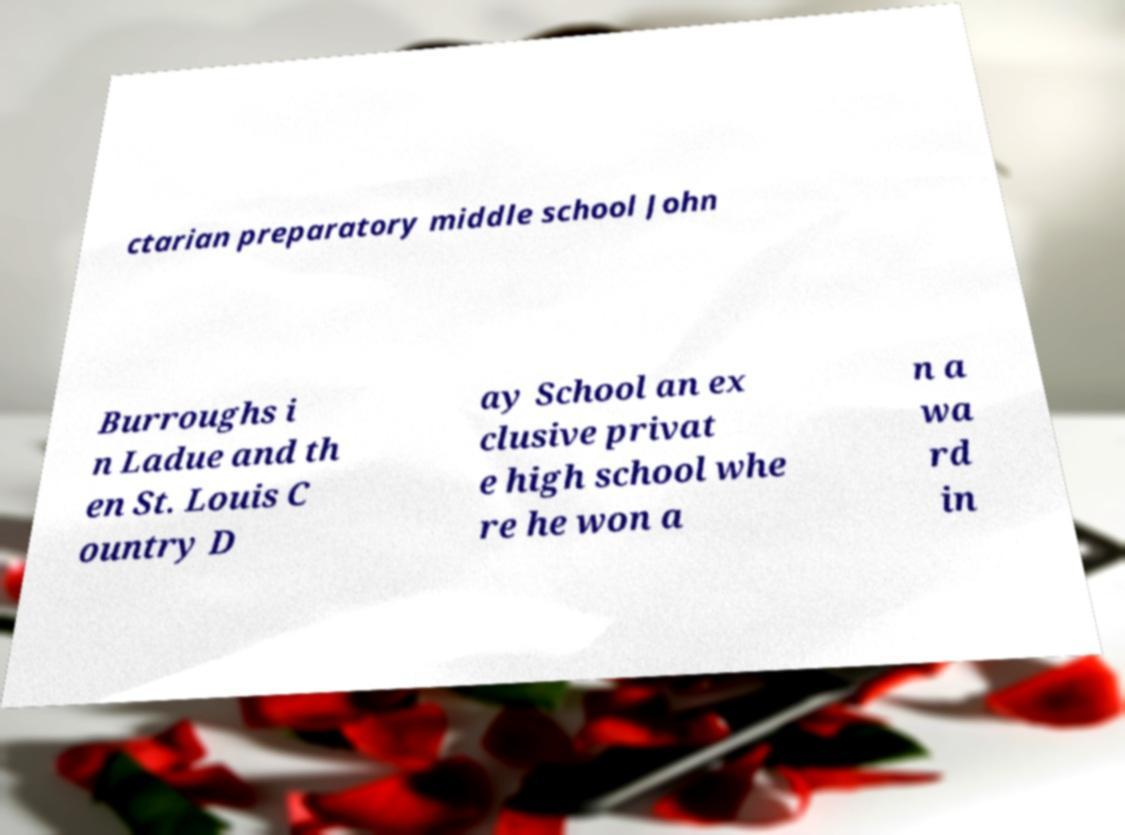Could you extract and type out the text from this image? ctarian preparatory middle school John Burroughs i n Ladue and th en St. Louis C ountry D ay School an ex clusive privat e high school whe re he won a n a wa rd in 